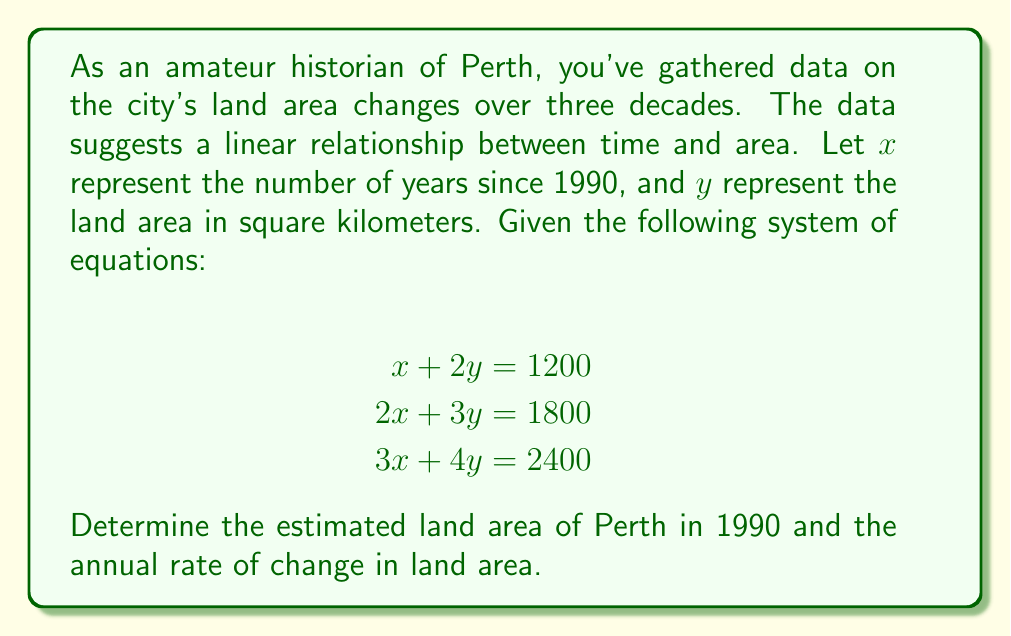Give your solution to this math problem. Let's solve this system of equations step by step:

1) We have three equations with two unknowns. We can solve this using elimination method.

2) Multiply the first equation by 2 and subtract it from the second equation:
   $$\begin{align}
   2(x + 2y) &= 2400 \\
   2x + 3y &= 1800 \\
   \hline
   y &= 600
   \end{align}$$

3) Now substitute $y = 600$ into the first equation:
   $$\begin{align}
   x + 2(600) &= 1200 \\
   x + 1200 &= 1200 \\
   x &= 0
   \end{align}$$

4) Interpret the results:
   - $x = 0$ corresponds to 1990 (our reference year)
   - $y = 600$ represents the land area in 1990

5) To find the annual rate of change, we can use any of the original equations. Let's use the first one:
   $$\begin{align}
   x + 2y &= 1200 \\
   x + 2(600) &= 1200 \\
   x &= 0
   \end{align}$$

   This means that for each year (x) that passes, the equation remains balanced without changing y. Therefore, the annual rate of change is 0 km²/year.

6) Verify with the other equations:
   $$\begin{align}
   2(0) + 3(600) &= 1800 \\
   3(0) + 4(600) &= 2400
   \end{align}$$
   Both equations hold true, confirming our solution.
Answer: Land area in 1990: 600 km²; Annual rate of change: 0 km²/year 